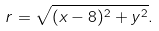Convert formula to latex. <formula><loc_0><loc_0><loc_500><loc_500>r = \sqrt { ( x - 8 ) ^ { 2 } + y ^ { 2 } } .</formula> 